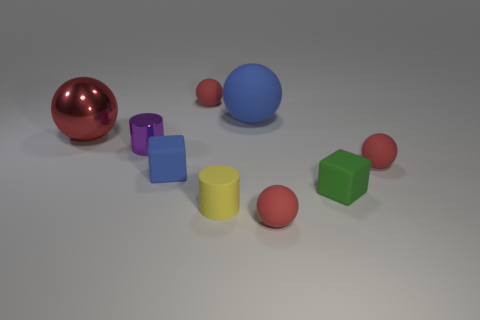Subtract all tiny matte spheres. How many spheres are left? 2 Add 1 blue metallic balls. How many objects exist? 10 Subtract all blue balls. How many balls are left? 4 Subtract all blocks. How many objects are left? 7 Subtract all blue cylinders. How many red spheres are left? 4 Subtract all yellow blocks. Subtract all gray spheres. How many blocks are left? 2 Add 7 small gray rubber spheres. How many small gray rubber spheres exist? 7 Subtract 0 gray cylinders. How many objects are left? 9 Subtract 2 balls. How many balls are left? 3 Subtract all purple metallic cylinders. Subtract all metallic cylinders. How many objects are left? 7 